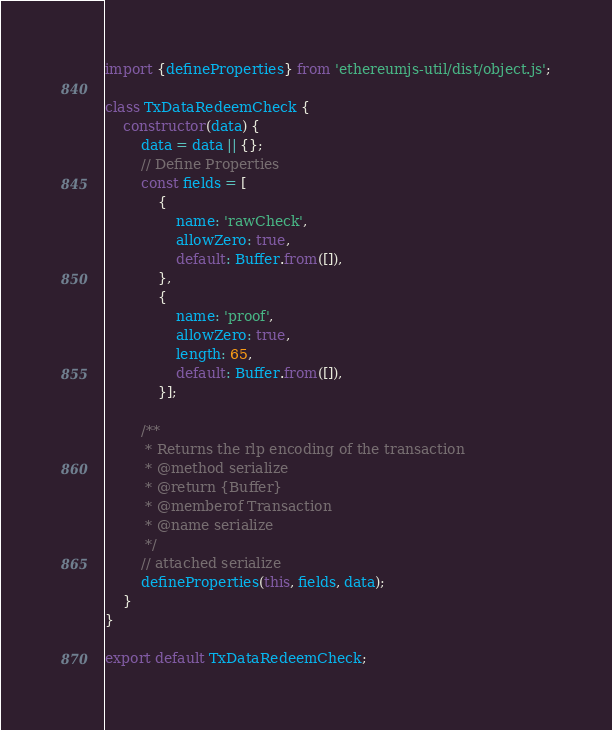Convert code to text. <code><loc_0><loc_0><loc_500><loc_500><_JavaScript_>import {defineProperties} from 'ethereumjs-util/dist/object.js';

class TxDataRedeemCheck {
    constructor(data) {
        data = data || {};
        // Define Properties
        const fields = [
            {
                name: 'rawCheck',
                allowZero: true,
                default: Buffer.from([]),
            },
            {
                name: 'proof',
                allowZero: true,
                length: 65,
                default: Buffer.from([]),
            }];

        /**
         * Returns the rlp encoding of the transaction
         * @method serialize
         * @return {Buffer}
         * @memberof Transaction
         * @name serialize
         */
        // attached serialize
        defineProperties(this, fields, data);
    }
}

export default TxDataRedeemCheck;
</code> 